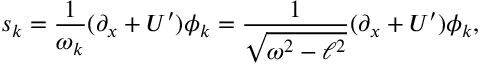Convert formula to latex. <formula><loc_0><loc_0><loc_500><loc_500>s _ { k } = \frac { 1 } { \omega _ { k } } ( \partial _ { x } + U { ^ { \prime } } ) \phi _ { k } = \frac { 1 } { \sqrt { \omega ^ { 2 } - \ell ^ { 2 } } } ( \partial _ { x } + U { ^ { \prime } } ) \phi _ { k } ,</formula> 